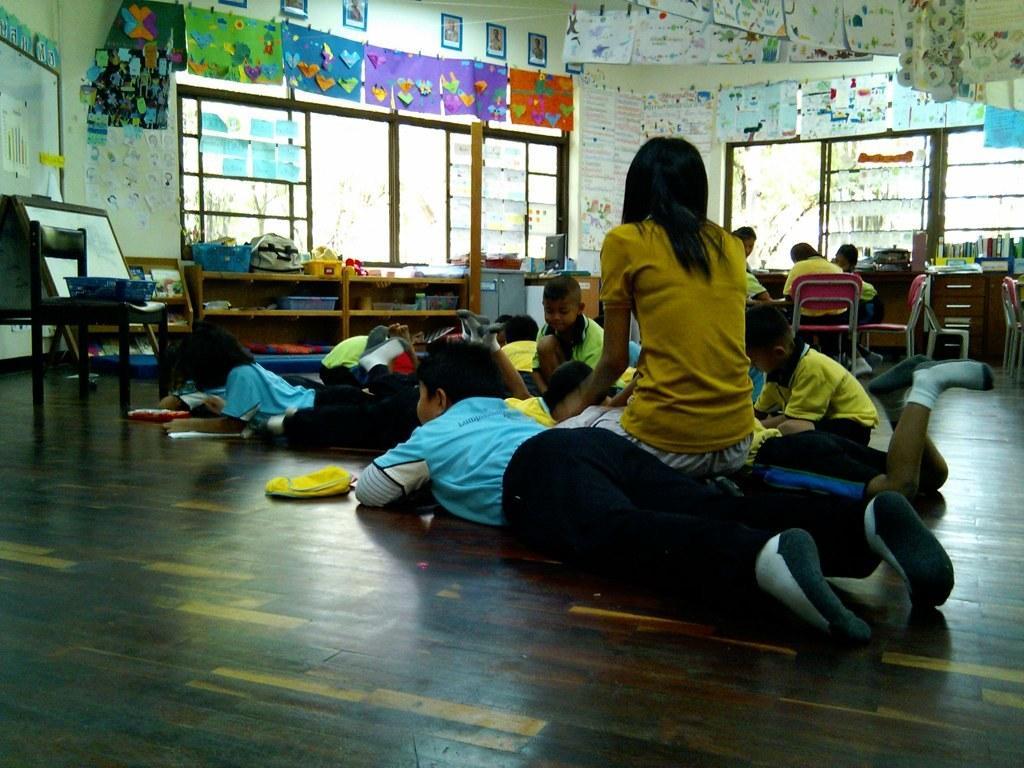How would you summarize this image in a sentence or two? Here we can see some persons are laying on the floor. This is chair and there is a board. Here we can see some persons are sitting on the chairs. On the background we can see many posts on the wall. This is window and there is a table. 